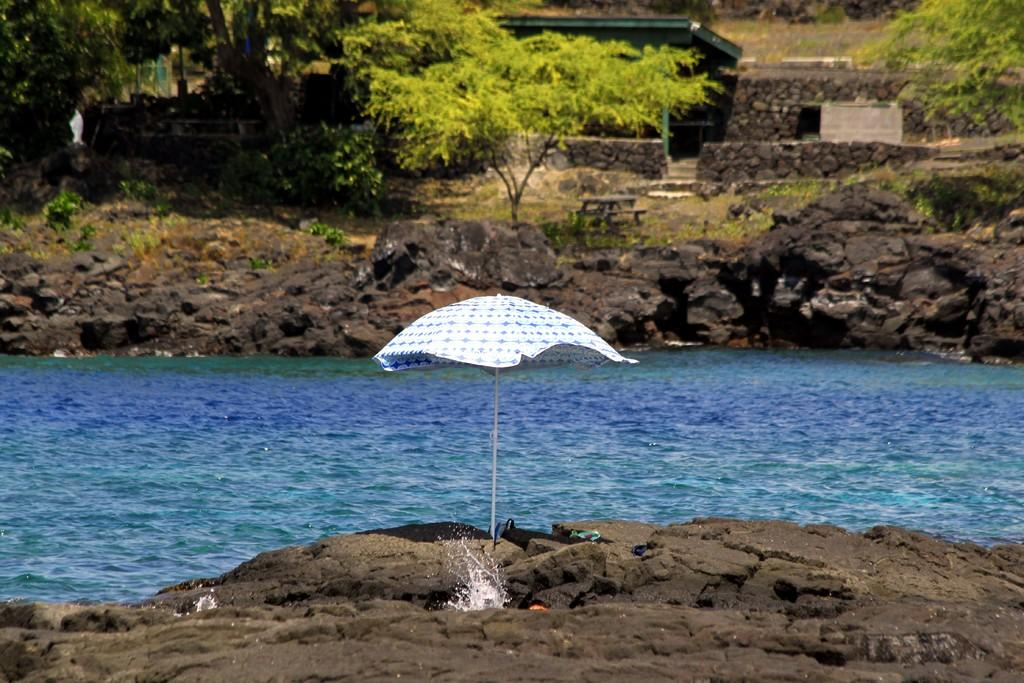What type of natural feature is present in the image? There is a river in the image. What surrounds the river on either side? There is a rock surface on either side of the river. What object can be seen between the rocks? There is an umbrella between the rocks. What can be seen in the background of the image? There are trees in the background of the image. What type of voice can be heard coming from the river in the image? There is no voice present in the image; it only features a river, rocks, an umbrella, and trees. Is there a sidewalk visible in the image? No, there is no sidewalk present in the image. 